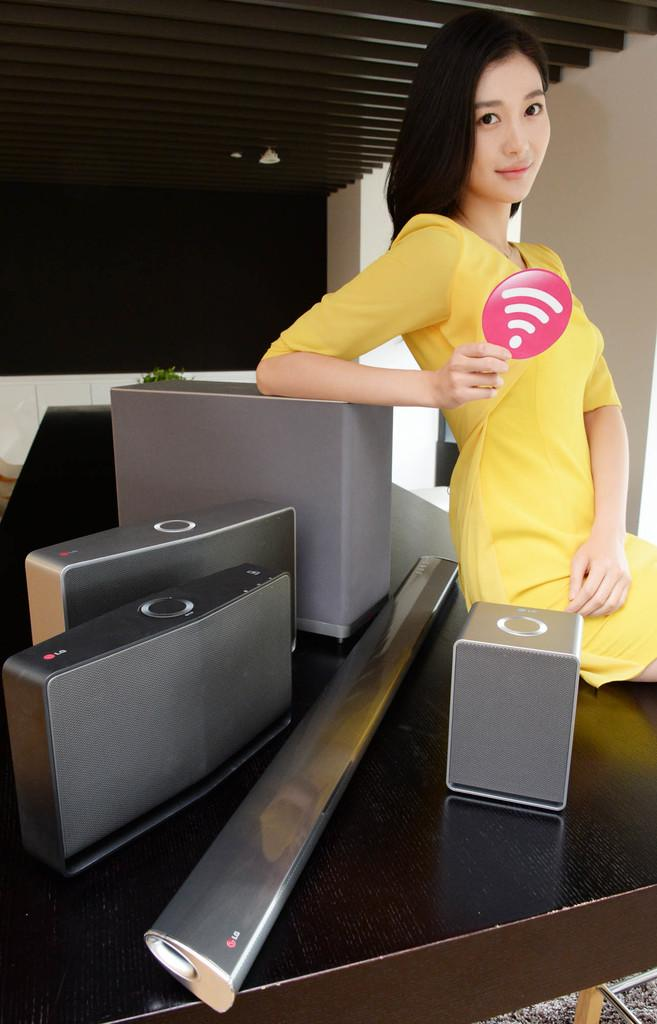What is the main object in the center of the image? There is a table in the center of the image. What is placed on the table? A chart, a box, a suitcase, and a sound box are present on the table. What is the lady on the table doing? The lady is sitting on the table and smiling. What can be seen in the background of the image? There is a wall and a pillar in the background of the image. How many quills are being used by the committee in the image? There is no committee or quills present in the image. What number is written on the chart in the image? The provided facts do not mention any specific numbers on the chart, so we cannot determine the number from the image. 